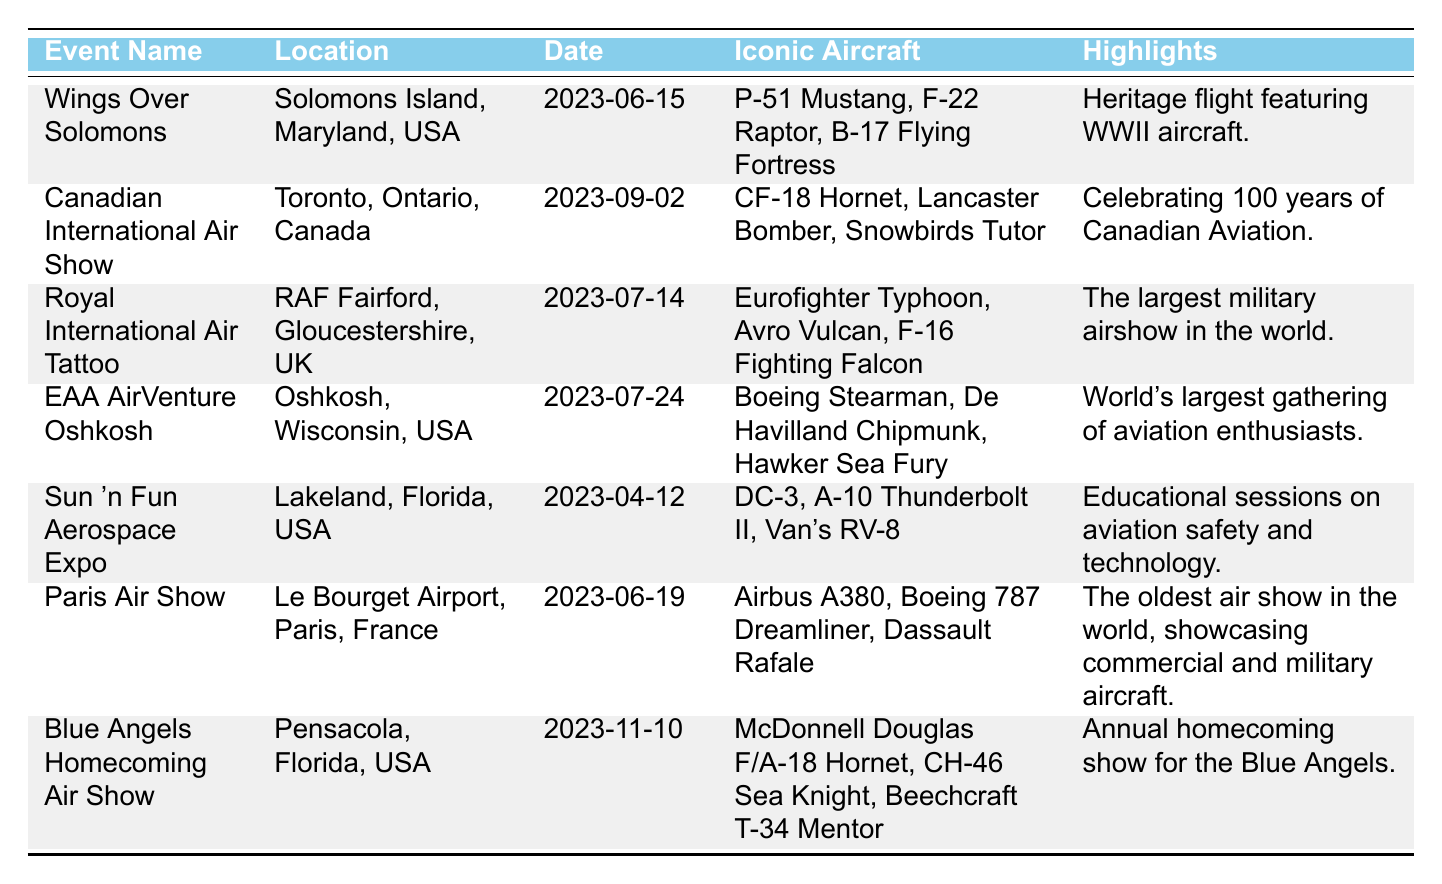What is the date of the Wings Over Solomons event? The table lists the event "Wings Over Solomons" and shows its corresponding date in the "Date" column, which is 2023-06-15.
Answer: 2023-06-15 Which aircraft is highlighted at the Canadian International Air Show? The table indicates that the iconic aircraft for the Canadian International Air Show includes CF-18 Hornet, Lancaster Bomber, and Snowbirds Tutor; CF-18 Hornet is one of them.
Answer: CF-18 Hornet Is the Royal International Air Tattoo held in the USA? Looking at the table, the location for the Royal International Air Tattoo is RAF Fairford, Gloucestershire, UK, which shows that it is not in the USA.
Answer: No What two events are scheduled in June 2023? The table displays "Wings Over Solomons" on 2023-06-15 and "Paris Air Show" on 2023-06-19 both in June 2023.
Answer: Wings Over Solomons and Paris Air Show How many events are happening after July 14, 2023? From the table, we find "EAA AirVenture Oshkosh" on 2023-07-24, "Canadian International Air Show" on 2023-09-02, and "Blue Angels Homecoming Air Show" on 2023-11-10 – that's three events after July 14, 2023.
Answer: 3 What is the highlight of the Sun 'n Fun Aerospace Expo? The table shows that the highlight of the Sun 'n Fun Aerospace Expo is "Educational sessions on aviation safety and technology," providing the answer directly from the information given.
Answer: Educational sessions on aviation safety and technology Which event features the Avro Vulcan? The table lists the "Royal International Air Tattoo" having Avro Vulcan among its iconic aircraft, thus identifying the event that features it.
Answer: Royal International Air Tattoo What is the most distant airshow event from the current date listed in the table? Analyzing the dates, "Blue Angels Homecoming Air Show" on 2023-11-10 has the furthest date when compared to others, making it the most distant airshow event.
Answer: Blue Angels Homecoming Air Show Which locations are hosting events in the USA? Upon examining the table, events located in the USA are "Wings Over Solomons," "EAA AirVenture Oshkosh," "Sun 'n Fun Aerospace Expo," and "Blue Angels Homecoming Air Show." Thus, the locations are Solomons Island, Oshkosh, Lakeland, and Pensacola respectively.
Answer: Solomons Island, Oshkosh, Lakeland, Pensacola 